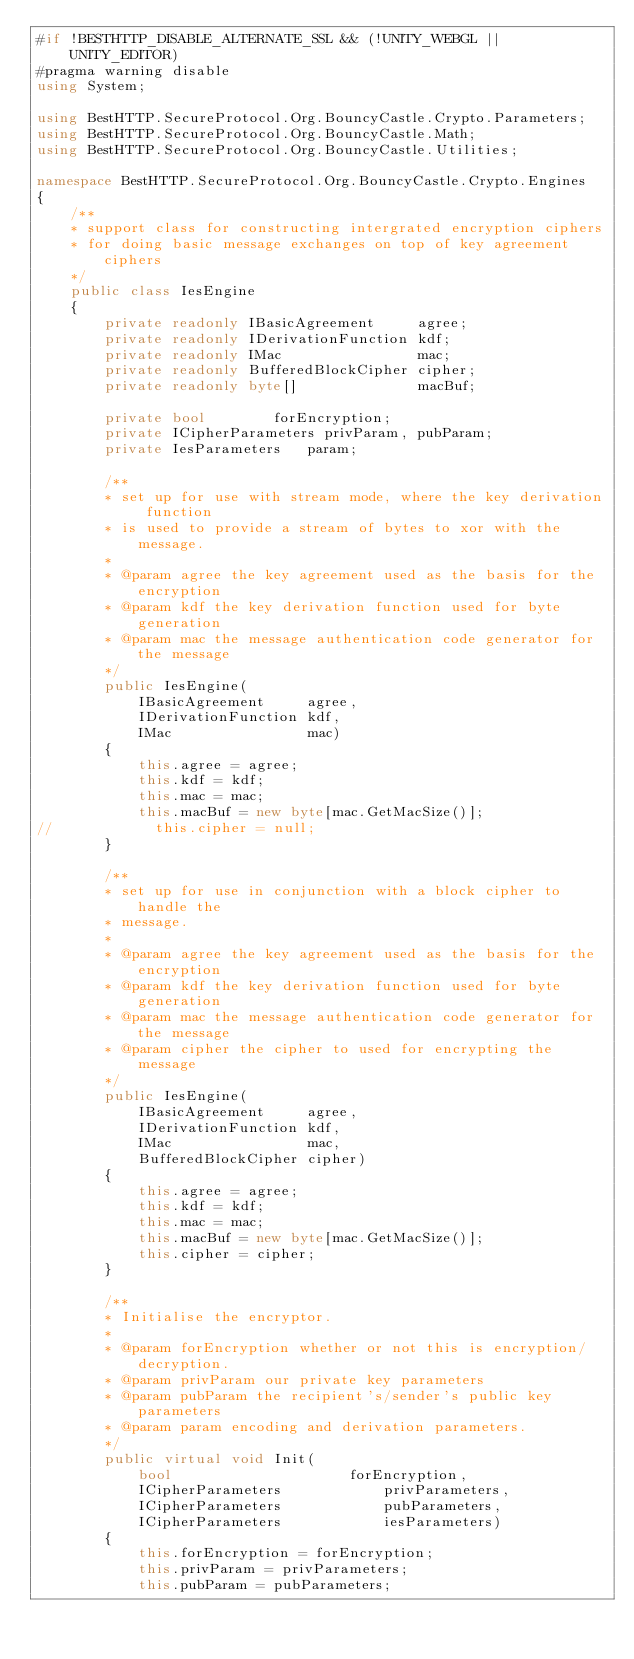Convert code to text. <code><loc_0><loc_0><loc_500><loc_500><_C#_>#if !BESTHTTP_DISABLE_ALTERNATE_SSL && (!UNITY_WEBGL || UNITY_EDITOR)
#pragma warning disable
using System;

using BestHTTP.SecureProtocol.Org.BouncyCastle.Crypto.Parameters;
using BestHTTP.SecureProtocol.Org.BouncyCastle.Math;
using BestHTTP.SecureProtocol.Org.BouncyCastle.Utilities;

namespace BestHTTP.SecureProtocol.Org.BouncyCastle.Crypto.Engines
{
    /**
    * support class for constructing intergrated encryption ciphers
    * for doing basic message exchanges on top of key agreement ciphers
    */
    public class IesEngine
    {
        private readonly IBasicAgreement     agree;
        private readonly IDerivationFunction kdf;
        private readonly IMac                mac;
        private readonly BufferedBlockCipher cipher;
        private readonly byte[]              macBuf;

        private bool				forEncryption;
        private ICipherParameters	privParam, pubParam;
        private IesParameters		param;

        /**
        * set up for use with stream mode, where the key derivation function
        * is used to provide a stream of bytes to xor with the message.
        *
        * @param agree the key agreement used as the basis for the encryption
        * @param kdf the key derivation function used for byte generation
        * @param mac the message authentication code generator for the message
        */
        public IesEngine(
            IBasicAgreement     agree,
            IDerivationFunction kdf,
            IMac                mac)
        {
            this.agree = agree;
            this.kdf = kdf;
            this.mac = mac;
            this.macBuf = new byte[mac.GetMacSize()];
//            this.cipher = null;
        }

        /**
        * set up for use in conjunction with a block cipher to handle the
        * message.
        *
        * @param agree the key agreement used as the basis for the encryption
        * @param kdf the key derivation function used for byte generation
        * @param mac the message authentication code generator for the message
        * @param cipher the cipher to used for encrypting the message
        */
        public IesEngine(
            IBasicAgreement     agree,
            IDerivationFunction kdf,
            IMac                mac,
            BufferedBlockCipher cipher)
        {
            this.agree = agree;
            this.kdf = kdf;
            this.mac = mac;
            this.macBuf = new byte[mac.GetMacSize()];
            this.cipher = cipher;
        }

        /**
        * Initialise the encryptor.
        *
        * @param forEncryption whether or not this is encryption/decryption.
        * @param privParam our private key parameters
        * @param pubParam the recipient's/sender's public key parameters
        * @param param encoding and derivation parameters.
        */
        public virtual void Init(
            bool                     forEncryption,
            ICipherParameters            privParameters,
            ICipherParameters            pubParameters,
            ICipherParameters            iesParameters)
        {
            this.forEncryption = forEncryption;
            this.privParam = privParameters;
            this.pubParam = pubParameters;</code> 